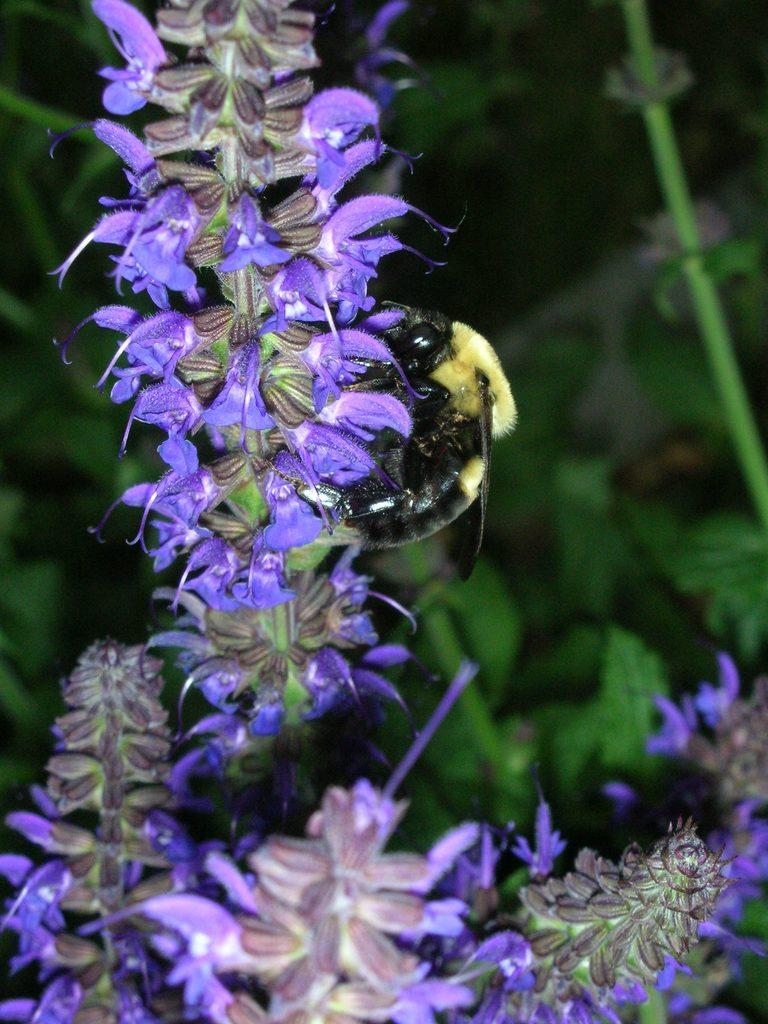What type of living organisms can be seen in the image? There are flowers and an insect in the image. What is the insect doing in the image? The insect is on a flower in the image. What can be seen in the background of the image? There are plants visible in the background of the image. What type of music is the insect playing on the flower in the image? There is no music or instrument present in the image, so the insect is not playing any music. 